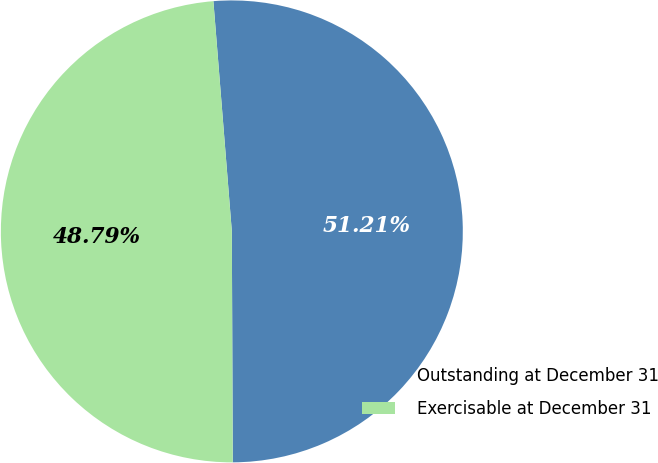<chart> <loc_0><loc_0><loc_500><loc_500><pie_chart><fcel>Outstanding at December 31<fcel>Exercisable at December 31<nl><fcel>51.21%<fcel>48.79%<nl></chart> 